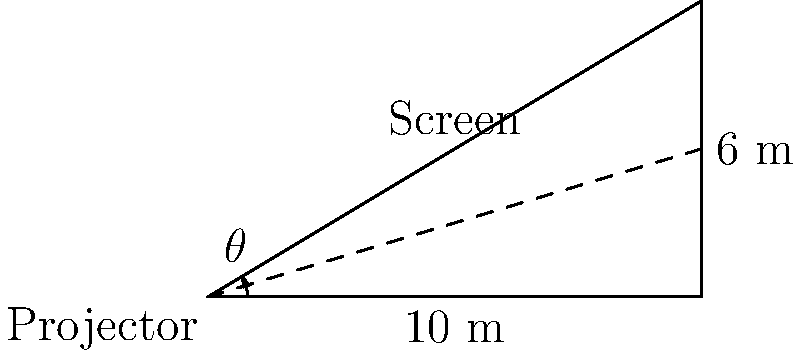As a software engineer developing a platform for global film distribution, you're tasked with optimizing projector setups. In a typical cinema setup, a projector is placed 10 meters away from a screen, and the center of the projection lens needs to hit the screen 6 meters above the floor for optimal image quality. What is the ideal tilt angle $\theta$ (in degrees, rounded to one decimal place) for the projector to achieve this optimal projection? To solve this problem, we'll use trigonometry. Let's approach this step-by-step:

1) We can treat this scenario as a right-angled triangle, where:
   - The base of the triangle is the distance from the projector to the screen (10 m)
   - The height of the triangle is the height of the projected image on the screen (6 m)
   - The angle we're looking for ($\theta$) is the angle between the base and the hypotenuse

2) In a right-angled triangle, the tangent of an angle is the ratio of the opposite side to the adjacent side.
   
   $\tan(\theta) = \frac{\text{opposite}}{\text{adjacent}} = \frac{\text{height}}{\text{base}}$

3) Substituting our known values:

   $\tan(\theta) = \frac{6}{10} = 0.6$

4) To find $\theta$, we need to use the inverse tangent (arctan or $\tan^{-1}$) function:

   $\theta = \tan^{-1}(0.6)$

5) Using a calculator or programming function to compute this:

   $\theta \approx 30.9637565$ degrees

6) Rounding to one decimal place as requested:

   $\theta \approx 30.9$ degrees

Therefore, the ideal tilt angle for the projector is approximately 30.9 degrees.
Answer: $30.9^{\circ}$ 